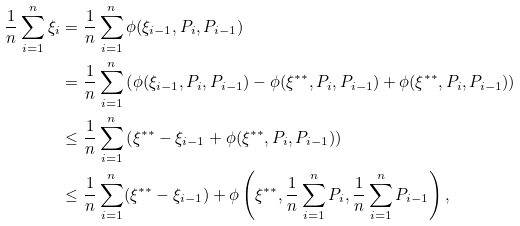<formula> <loc_0><loc_0><loc_500><loc_500>\frac { 1 } { n } \sum _ { i = 1 } ^ { n } \xi _ { i } & = \frac { 1 } { n } \sum _ { i = 1 } ^ { n } \phi ( \xi _ { i - 1 } , P _ { i } , P _ { i - 1 } ) \\ & = \frac { 1 } { n } \sum _ { i = 1 } ^ { n } \left ( \phi ( \xi _ { i - 1 } , P _ { i } , P _ { i - 1 } ) - \phi ( \xi ^ { * * } , P _ { i } , P _ { i - 1 } ) + \phi ( \xi ^ { * * } , P _ { i } , P _ { i - 1 } ) \right ) \\ & \leq \frac { 1 } { n } \sum _ { i = 1 } ^ { n } \left ( \xi ^ { * * } - \xi _ { i - 1 } + \phi ( \xi ^ { * * } , P _ { i } , P _ { i - 1 } ) \right ) \\ & \leq \frac { 1 } { n } \sum _ { i = 1 } ^ { n } ( \xi ^ { * * } - \xi _ { i - 1 } ) + \phi \left ( \xi ^ { * * } , \frac { 1 } { n } \sum _ { i = 1 } ^ { n } P _ { i } , \frac { 1 } { n } \sum _ { i = 1 } ^ { n } P _ { i - 1 } \right ) ,</formula> 